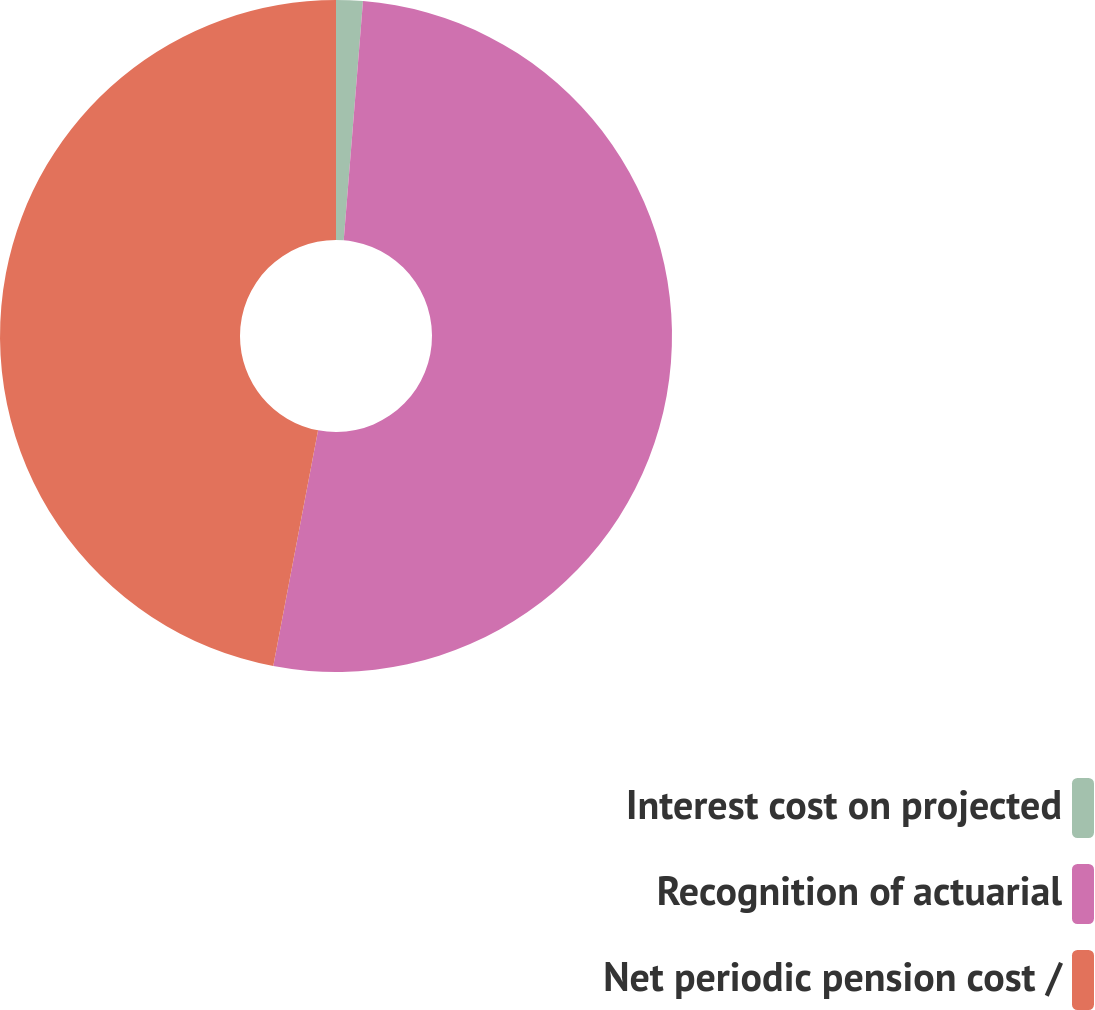<chart> <loc_0><loc_0><loc_500><loc_500><pie_chart><fcel>Interest cost on projected<fcel>Recognition of actuarial<fcel>Net periodic pension cost /<nl><fcel>1.28%<fcel>51.71%<fcel>47.01%<nl></chart> 